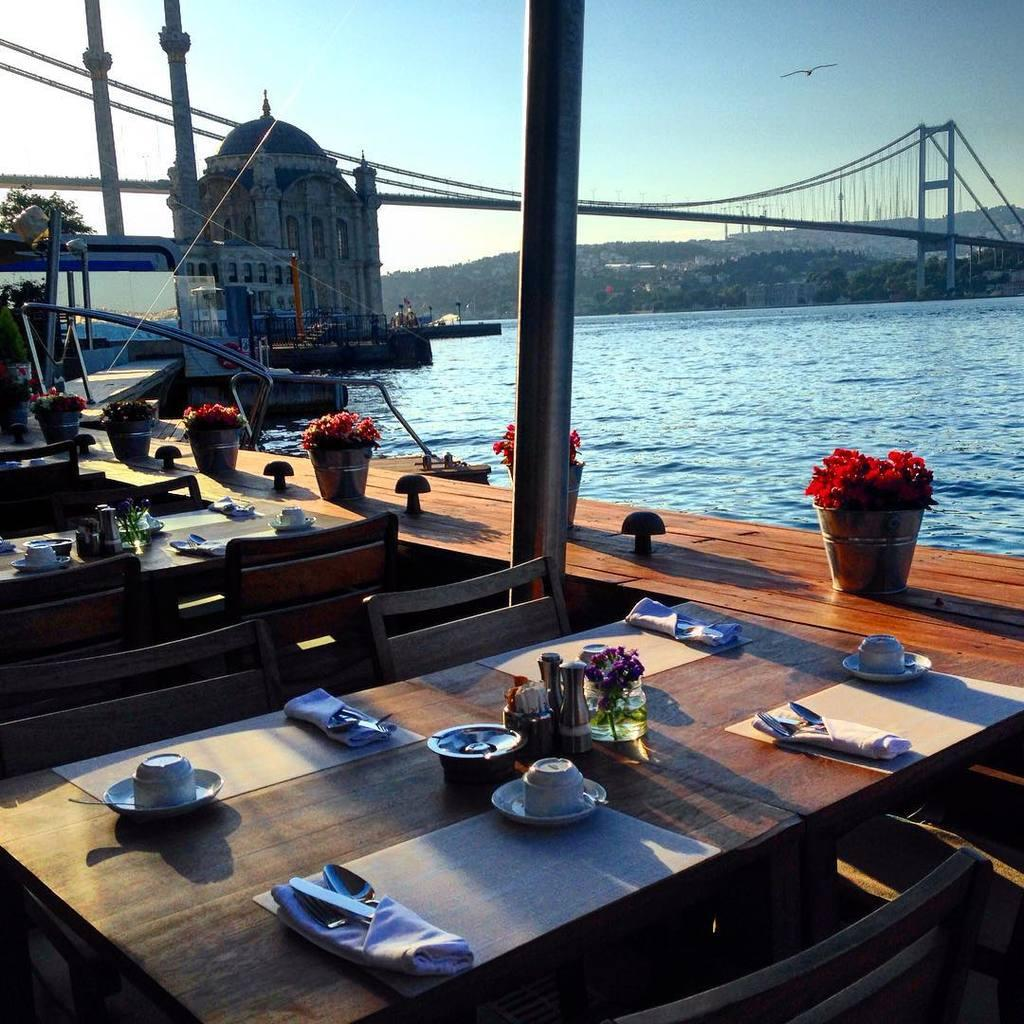What type of furniture can be seen in the image? There are chairs and tables in the image. What items are on the table in the image? There is a cup, a saucer, a glass, a flower, a cloth, and a spoon on the table in the image. What is the setting of the image? The image features a bridge and water, suggesting it might be near a body of water. What can be seen in the sky in the image? There is a bird and sky visible in the image. What type of spring is visible in the image? There is no spring present in the image. What button is being used to control the bird in the image? There is no button or control mechanism for the bird in the image, as it is a real bird flying in the sky. 